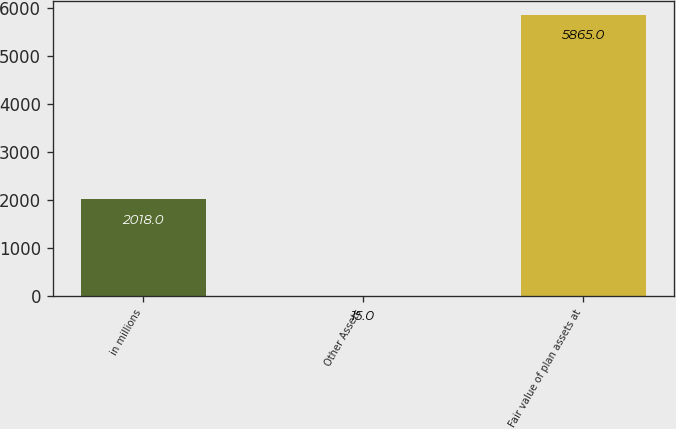<chart> <loc_0><loc_0><loc_500><loc_500><bar_chart><fcel>in millions<fcel>Other Assets<fcel>Fair value of plan assets at<nl><fcel>2018<fcel>15<fcel>5865<nl></chart> 